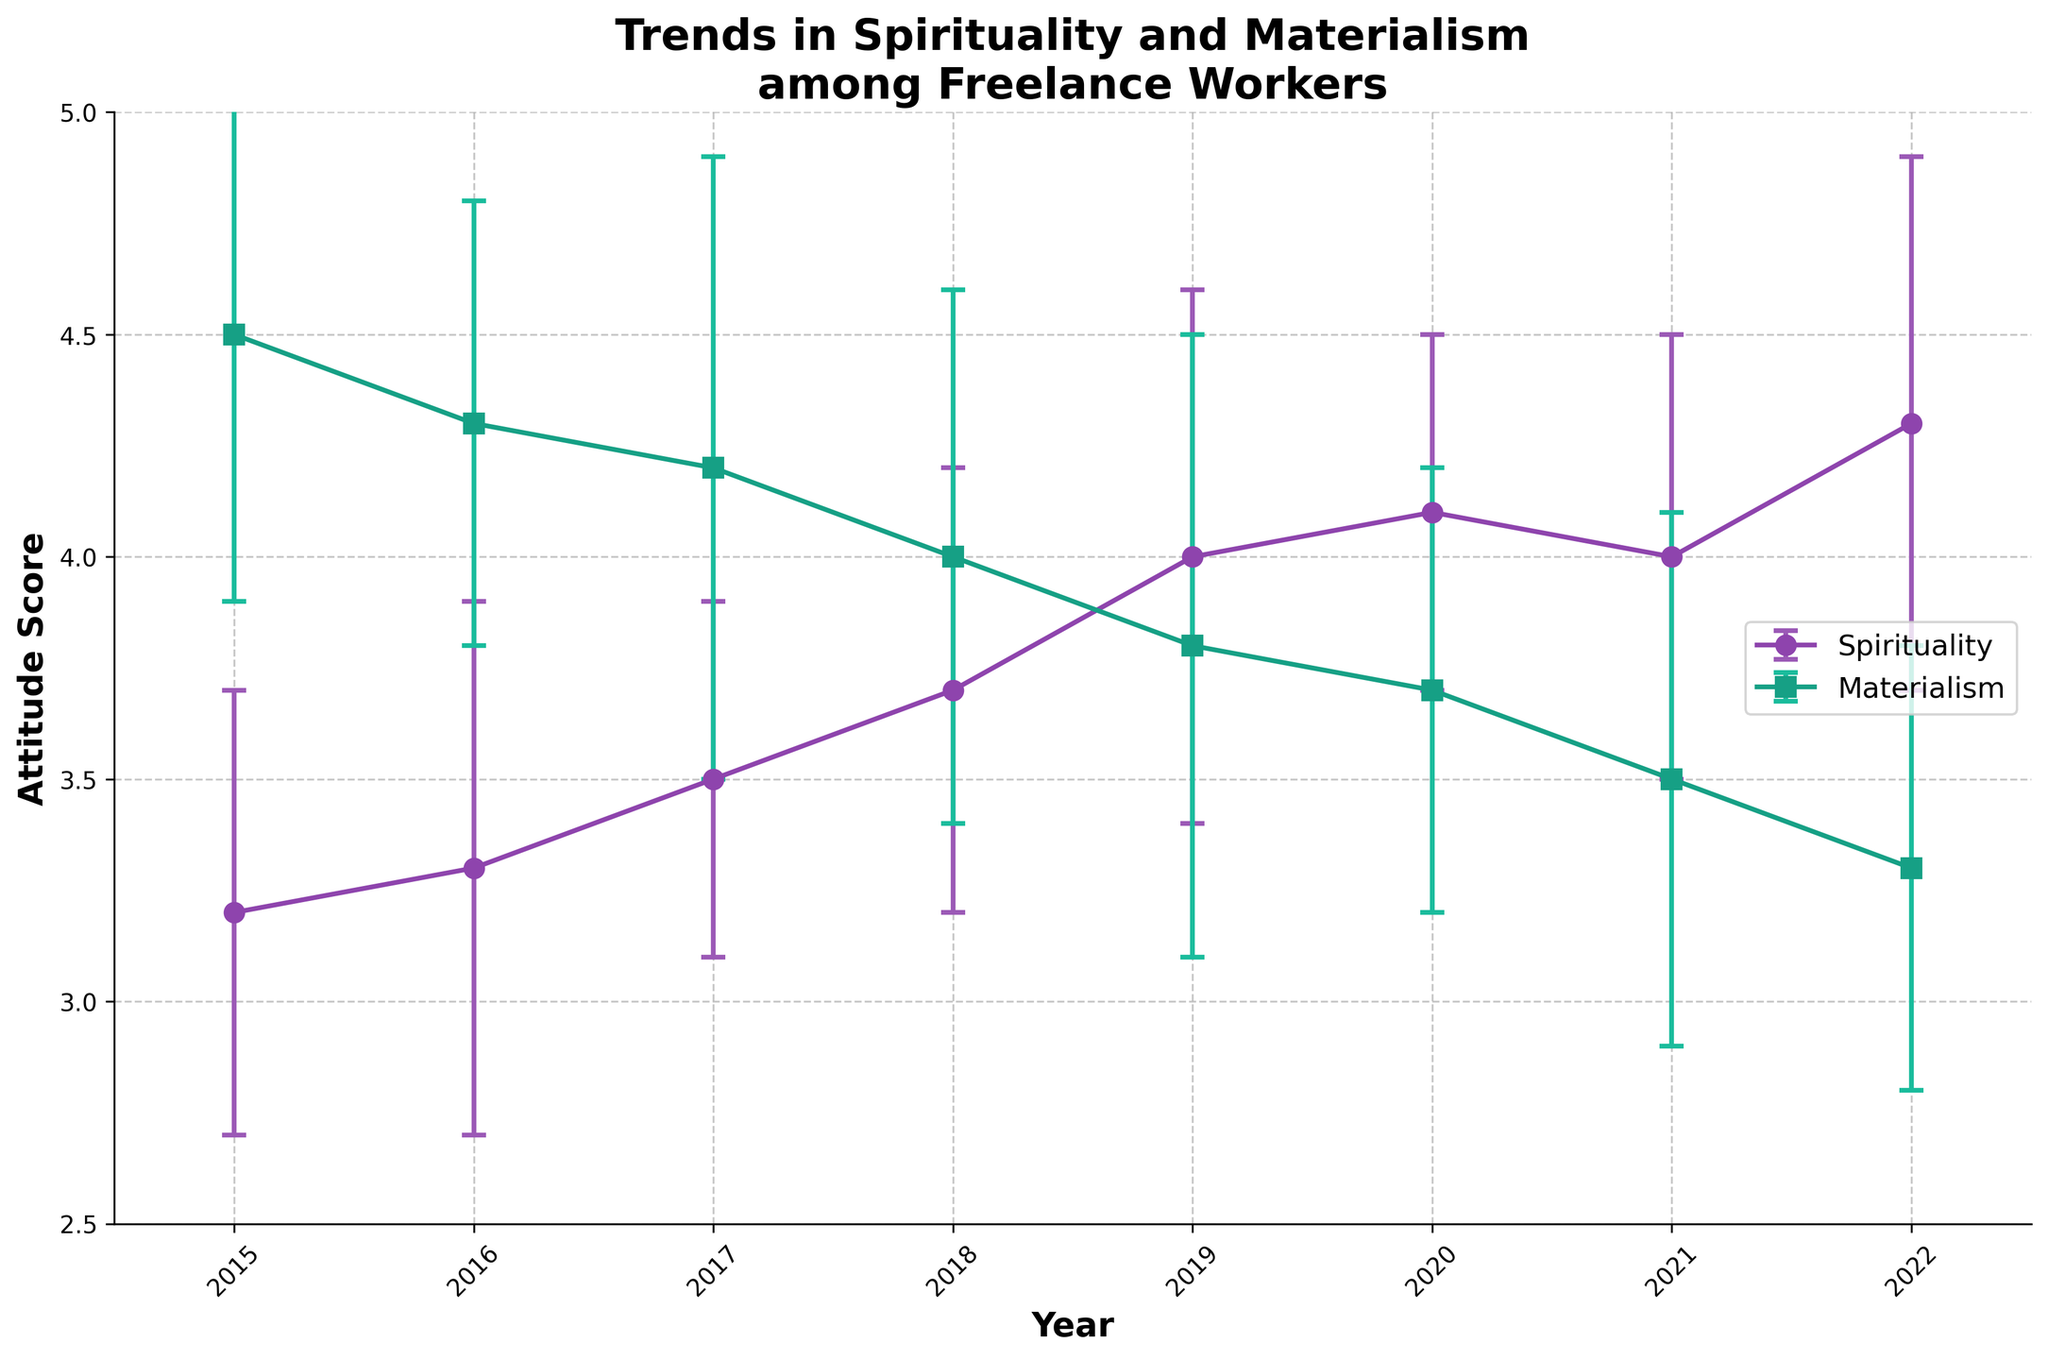How many data points are shown for each trend? To find the number of data points, count the distinct points or markers on the graph for both Spirituality and Materialism. By counting, we see there are 8 data points (2015 to 2022).
Answer: 8 What year shows the highest mean attitude toward spirituality? Look at the data points labeled for Spirituality and identify the one with the highest mean value. The highest point is in 2022 with a mean of 4.3.
Answer: 2022 Between which consecutive years did materialism show the greatest decrease? Examine the values for Materialism and calculate the decrease between each pair of consecutive years. The largest decrease is from 2018 (4.0) to 2019 (3.8), showing a decrease of 0.2.
Answer: 2018 to 2019 What is the range of variability for spirituality means in 2021? The variability range is given as the error bars. For 2021, the mean is 4.0 with a standard deviation of 0.5, giving a range of 3.5 to 4.5.
Answer: [3.5, 4.5] Which year shows the smallest variation in materialism values? Check the error bars for Materialism for each year and identify the one with the smallest range. The smallest error bar for Materialism appears in 2020, with a standard deviation of ±0.5.
Answer: 2020 By how much did the mean attitude toward spirituality increase from 2015 to 2022? Subtract the mean for Spirituality in 2015 from the mean in 2022. The mean increased from 3.2 to 4.3, resulting in an increase of 4.3 - 3.2 = 1.1
Answer: 1.1 What was the mean attitude toward materialism in 2017, and how does it compare to spirituality in the same year? Find the mean values for both Materialism and Spirituality in 2017 and compare them. In 2017, Materialism is 4.2 and Spirituality is 3.5, making Materialism higher.
Answer: Materialism means: 4.2; Comparison: Materialism is higher than spirituality Which year shows the closest mean values for spirituality and materialism? Calculate the absolute differences between the means for Spirituality and Materialism for each year and find the smallest difference. In 2020, the difference is 4.1 - 3.7 = 0.4, the smallest among all years.
Answer: 2020 Overall, how did the trends in spirituality and materialism change from 2015 to 2022? Observe the overall direction and changes in the trends from 2015 to 2022. Spirituality shows a generally increasing trend, whereas Materialism shows a generally decreasing trend.
Answer: Spirituality increased, Materialism decreased In which year did spirituality exhibit the highest variability, and what was the standard deviation? Look at the error bars for Spirituality and identify the year with the largest error bar. The highest variability is shown in 2022, with a standard deviation of 0.6.
Answer: 2022, 0.6 